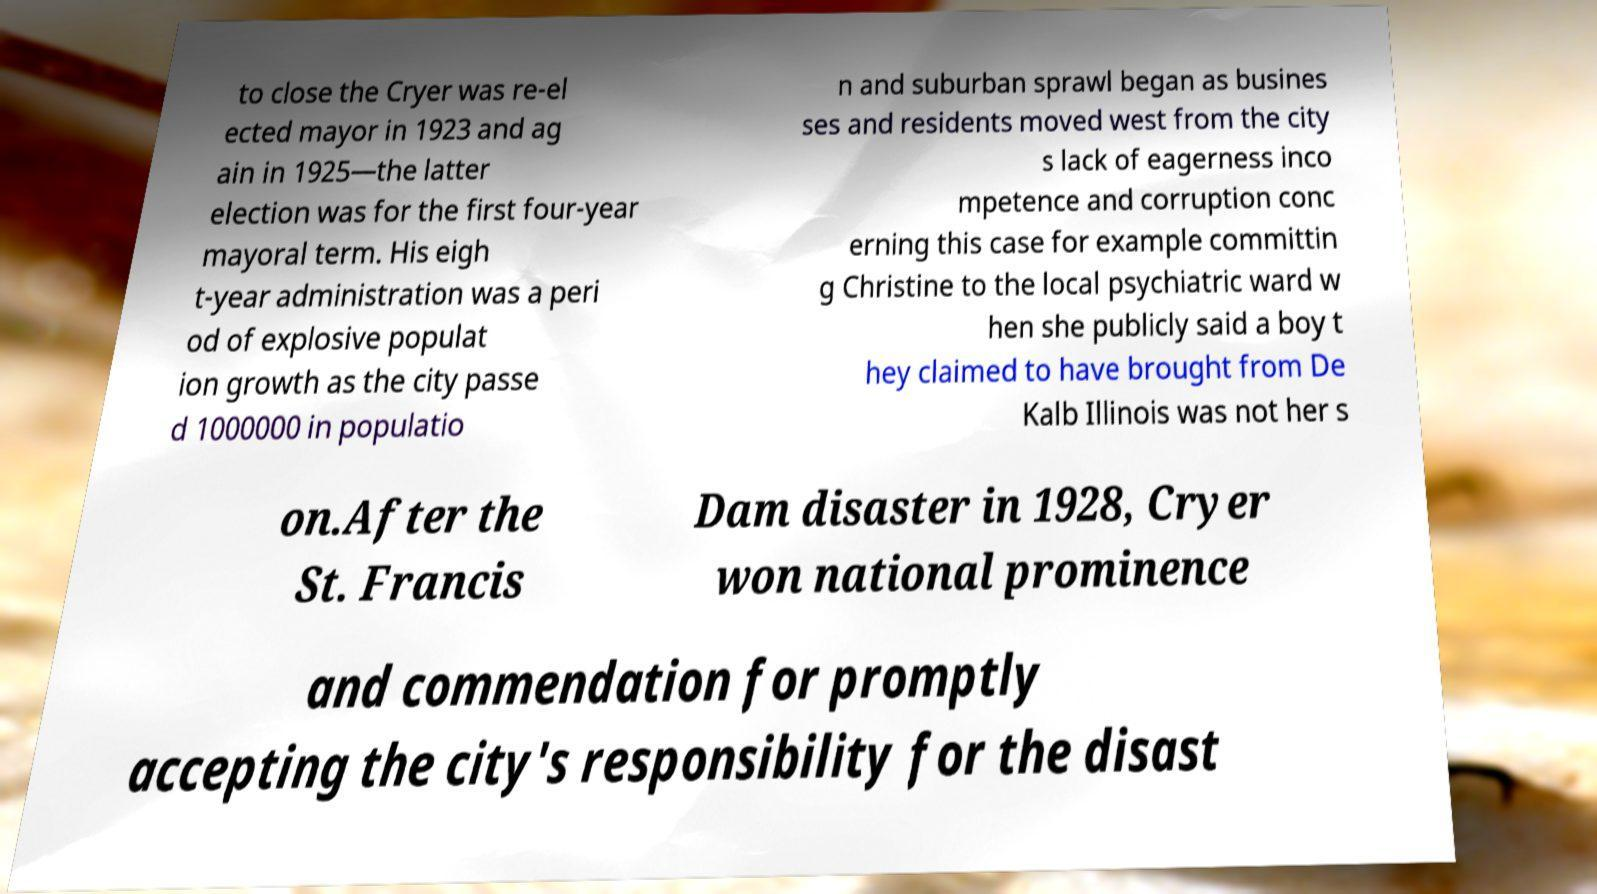Please read and relay the text visible in this image. What does it say? to close the Cryer was re-el ected mayor in 1923 and ag ain in 1925—the latter election was for the first four-year mayoral term. His eigh t-year administration was a peri od of explosive populat ion growth as the city passe d 1000000 in populatio n and suburban sprawl began as busines ses and residents moved west from the city s lack of eagerness inco mpetence and corruption conc erning this case for example committin g Christine to the local psychiatric ward w hen she publicly said a boy t hey claimed to have brought from De Kalb Illinois was not her s on.After the St. Francis Dam disaster in 1928, Cryer won national prominence and commendation for promptly accepting the city's responsibility for the disast 